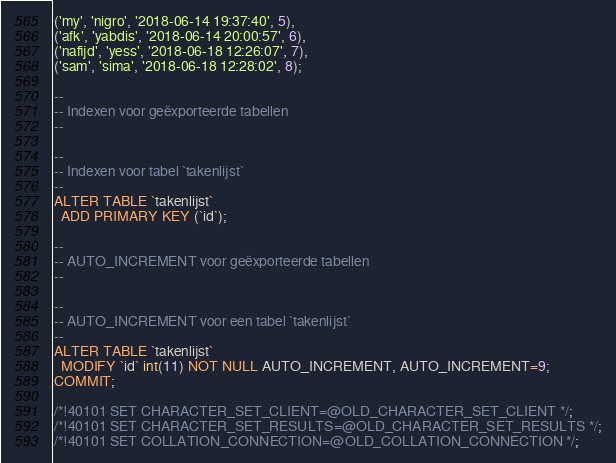<code> <loc_0><loc_0><loc_500><loc_500><_SQL_>('my', 'nigro', '2018-06-14 19:37:40', 5),
('afk', 'yabdis', '2018-06-14 20:00:57', 6),
('nafijd', 'yess', '2018-06-18 12:26:07', 7),
('sam', 'sima', '2018-06-18 12:28:02', 8);

--
-- Indexen voor geëxporteerde tabellen
--

--
-- Indexen voor tabel `takenlijst`
--
ALTER TABLE `takenlijst`
  ADD PRIMARY KEY (`id`);

--
-- AUTO_INCREMENT voor geëxporteerde tabellen
--

--
-- AUTO_INCREMENT voor een tabel `takenlijst`
--
ALTER TABLE `takenlijst`
  MODIFY `id` int(11) NOT NULL AUTO_INCREMENT, AUTO_INCREMENT=9;
COMMIT;

/*!40101 SET CHARACTER_SET_CLIENT=@OLD_CHARACTER_SET_CLIENT */;
/*!40101 SET CHARACTER_SET_RESULTS=@OLD_CHARACTER_SET_RESULTS */;
/*!40101 SET COLLATION_CONNECTION=@OLD_COLLATION_CONNECTION */;
</code> 